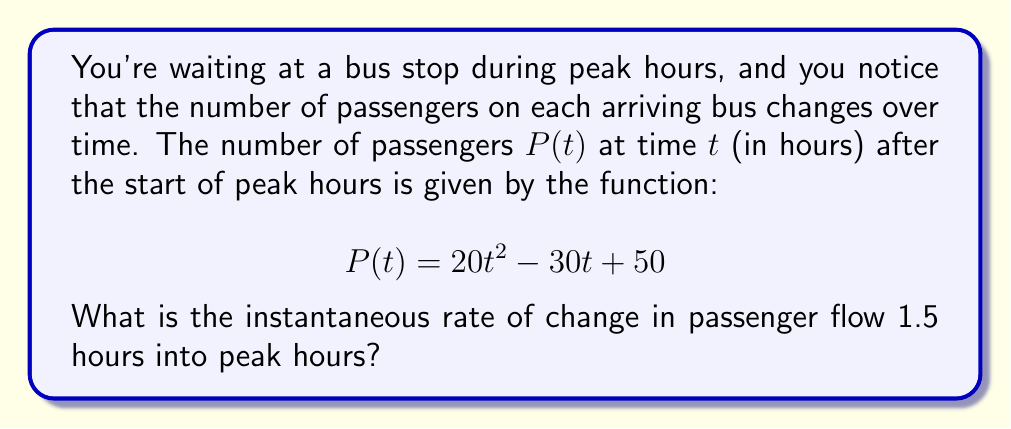Teach me how to tackle this problem. To find the instantaneous rate of change, we need to calculate the derivative of the given function and evaluate it at $t = 1.5$ hours.

Step 1: Find the derivative of $P(t)$.
The derivative of $P(t)$ with respect to $t$ is:
$$P'(t) = \frac{d}{dt}(20t^2 - 30t + 50)$$
$$P'(t) = 40t - 30$$

Step 2: Evaluate the derivative at $t = 1.5$ hours.
$$P'(1.5) = 40(1.5) - 30$$
$$P'(1.5) = 60 - 30 = 30$$

Therefore, the instantaneous rate of change in passenger flow 1.5 hours into peak hours is 30 passengers per hour.
Answer: 30 passengers/hour 